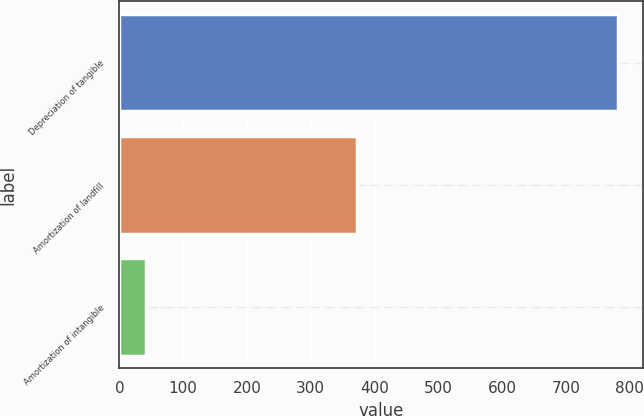<chart> <loc_0><loc_0><loc_500><loc_500><bar_chart><fcel>Depreciation of tangible<fcel>Amortization of landfill<fcel>Amortization of intangible<nl><fcel>781<fcel>372<fcel>41<nl></chart> 